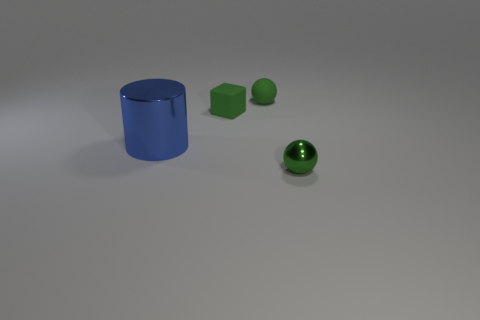Add 2 small green rubber objects. How many objects exist? 6 Add 3 small green spheres. How many small green spheres are left? 5 Add 3 tiny green balls. How many tiny green balls exist? 5 Subtract 0 red balls. How many objects are left? 4 Subtract all cubes. How many objects are left? 3 Subtract all large yellow rubber things. Subtract all tiny rubber cubes. How many objects are left? 3 